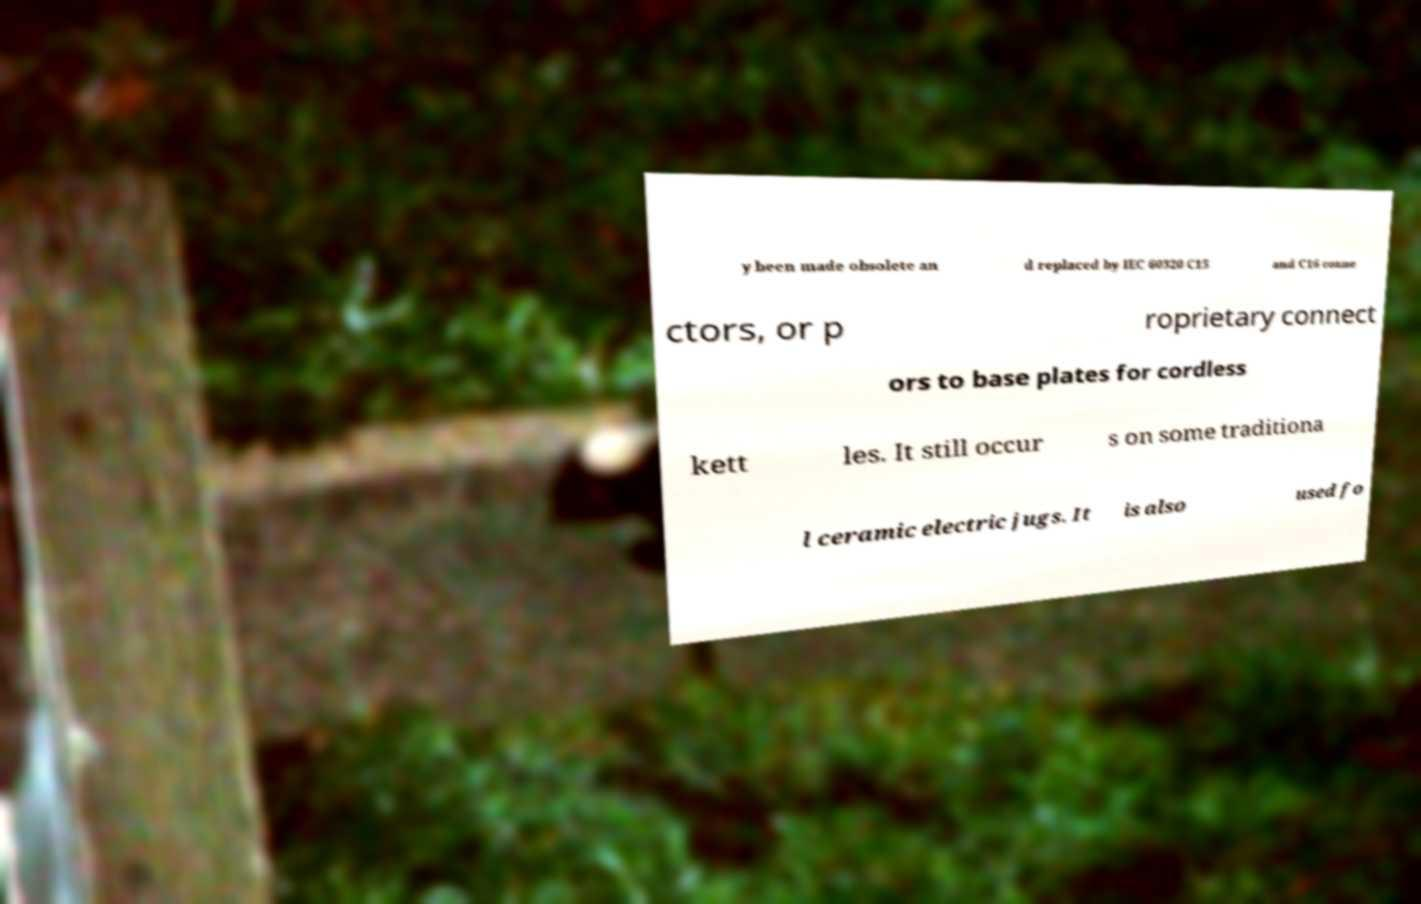Can you accurately transcribe the text from the provided image for me? y been made obsolete an d replaced by IEC 60320 C15 and C16 conne ctors, or p roprietary connect ors to base plates for cordless kett les. It still occur s on some traditiona l ceramic electric jugs. It is also used fo 